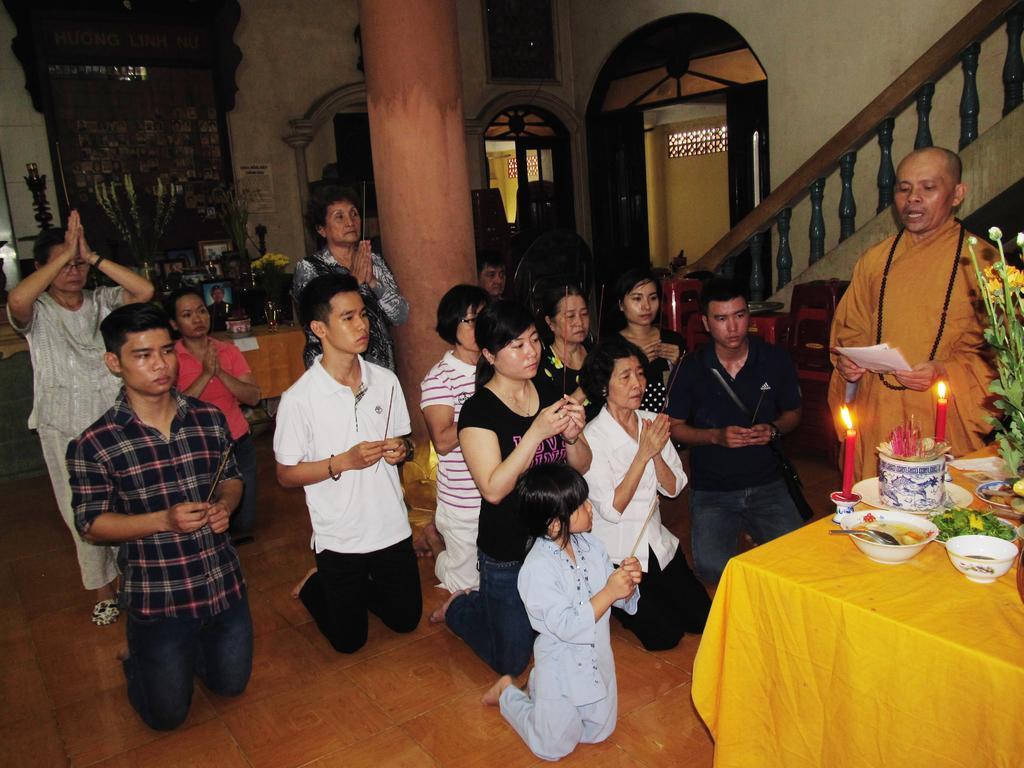Can you describe this image briefly? In this picture we can see all the persons kneeling down on the floor and praying. Here we can see one man holding a paper in his hand and talking. On the table we can see bowls, food, candles, flower bouquet. We can see two women standing and praying here. These are doors. we can see pillar and stairs here. 